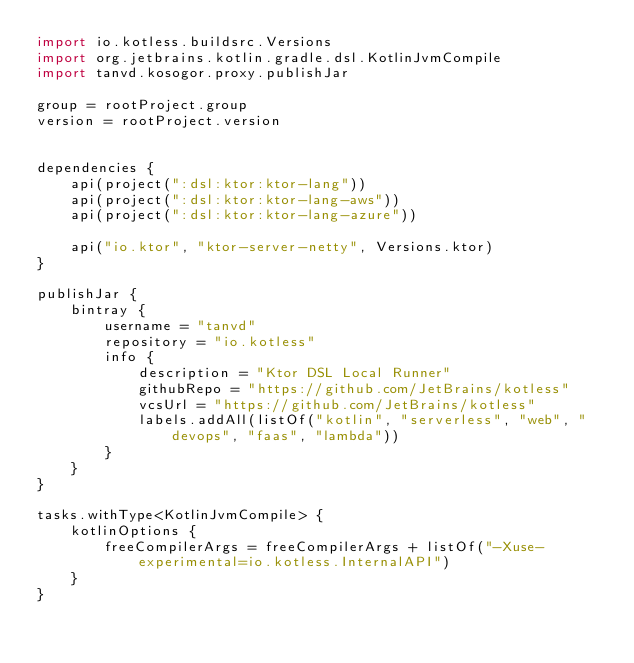Convert code to text. <code><loc_0><loc_0><loc_500><loc_500><_Kotlin_>import io.kotless.buildsrc.Versions
import org.jetbrains.kotlin.gradle.dsl.KotlinJvmCompile
import tanvd.kosogor.proxy.publishJar

group = rootProject.group
version = rootProject.version


dependencies {
    api(project(":dsl:ktor:ktor-lang"))
    api(project(":dsl:ktor:ktor-lang-aws"))
    api(project(":dsl:ktor:ktor-lang-azure"))

    api("io.ktor", "ktor-server-netty", Versions.ktor)
}

publishJar {
    bintray {
        username = "tanvd"
        repository = "io.kotless"
        info {
            description = "Ktor DSL Local Runner"
            githubRepo = "https://github.com/JetBrains/kotless"
            vcsUrl = "https://github.com/JetBrains/kotless"
            labels.addAll(listOf("kotlin", "serverless", "web", "devops", "faas", "lambda"))
        }
    }
}

tasks.withType<KotlinJvmCompile> {
    kotlinOptions {
        freeCompilerArgs = freeCompilerArgs + listOf("-Xuse-experimental=io.kotless.InternalAPI")
    }
}
</code> 